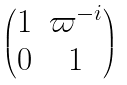<formula> <loc_0><loc_0><loc_500><loc_500>\begin{pmatrix} 1 & \varpi ^ { - i } \\ 0 & 1 \end{pmatrix}</formula> 